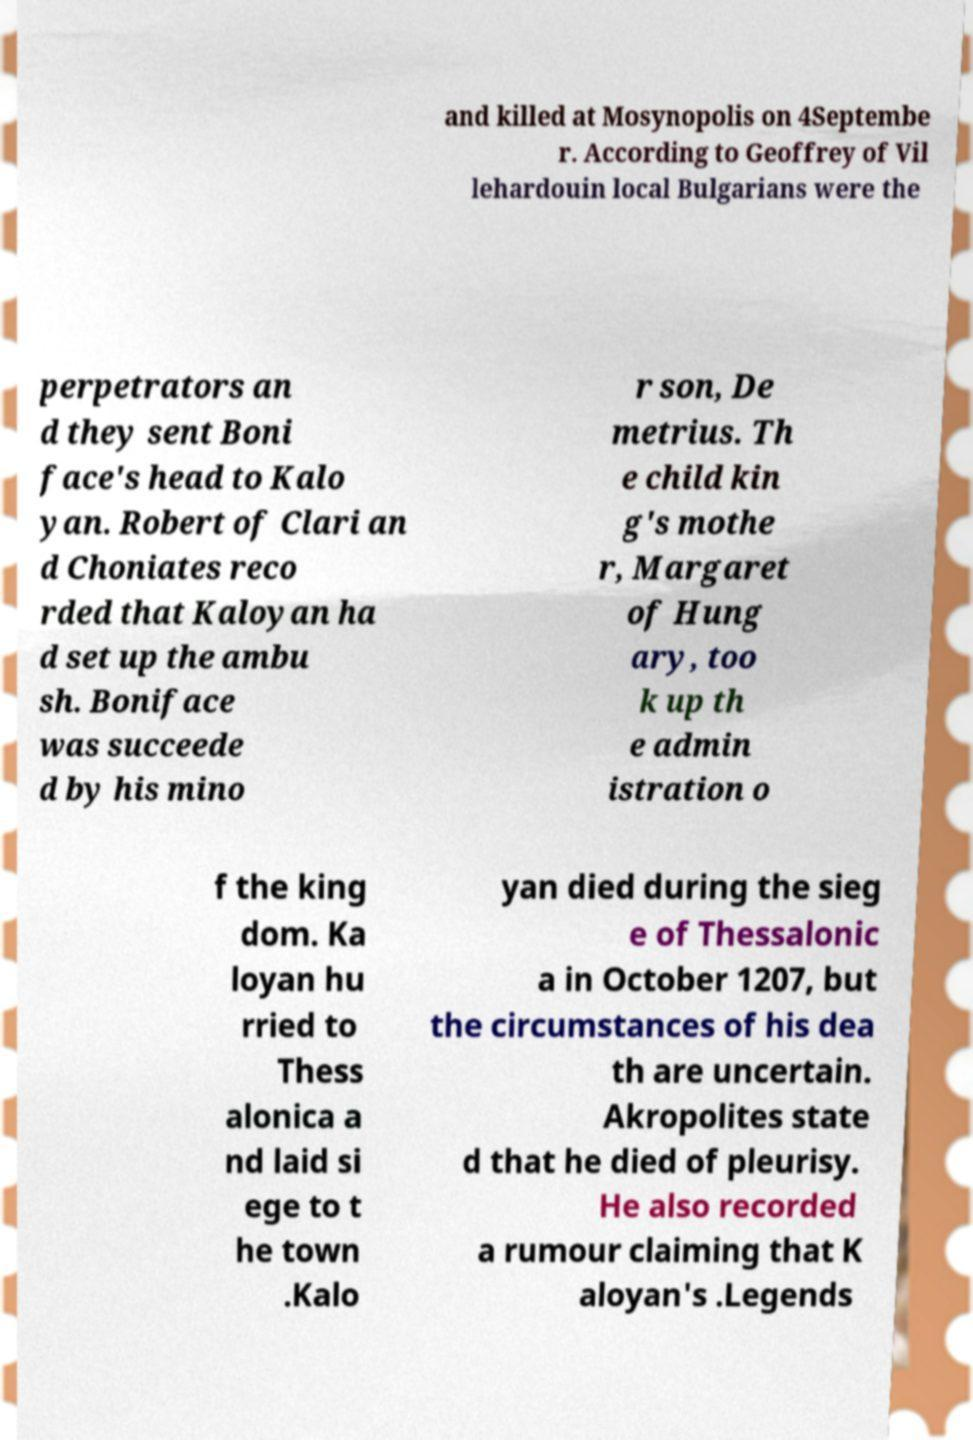Please read and relay the text visible in this image. What does it say? and killed at Mosynopolis on 4Septembe r. According to Geoffrey of Vil lehardouin local Bulgarians were the perpetrators an d they sent Boni face's head to Kalo yan. Robert of Clari an d Choniates reco rded that Kaloyan ha d set up the ambu sh. Boniface was succeede d by his mino r son, De metrius. Th e child kin g's mothe r, Margaret of Hung ary, too k up th e admin istration o f the king dom. Ka loyan hu rried to Thess alonica a nd laid si ege to t he town .Kalo yan died during the sieg e of Thessalonic a in October 1207, but the circumstances of his dea th are uncertain. Akropolites state d that he died of pleurisy. He also recorded a rumour claiming that K aloyan's .Legends 